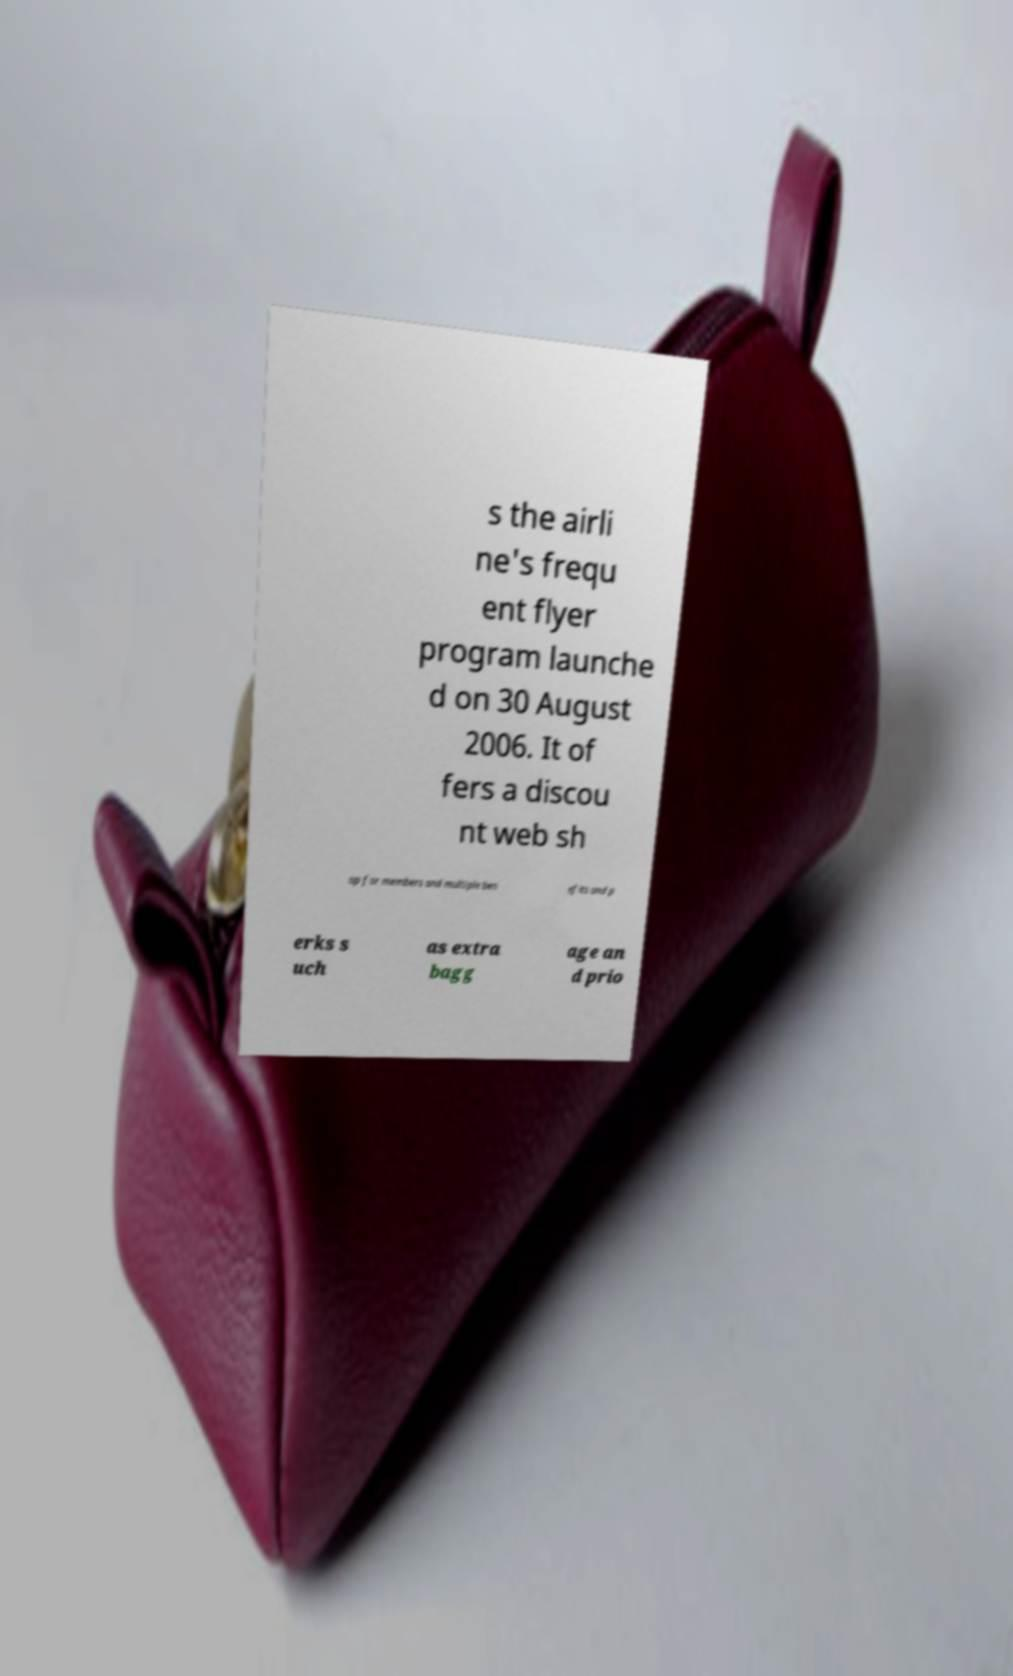Please read and relay the text visible in this image. What does it say? s the airli ne's frequ ent flyer program launche d on 30 August 2006. It of fers a discou nt web sh op for members and multiple ben efits and p erks s uch as extra bagg age an d prio 